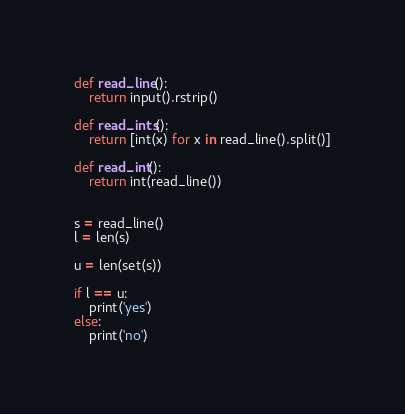Convert code to text. <code><loc_0><loc_0><loc_500><loc_500><_Python_>def read_line():
    return input().rstrip()

def read_ints():
    return [int(x) for x in read_line().split()]

def read_int():
    return int(read_line())


s = read_line()
l = len(s)

u = len(set(s))

if l == u:
    print('yes')
else:
    print('no')
</code> 